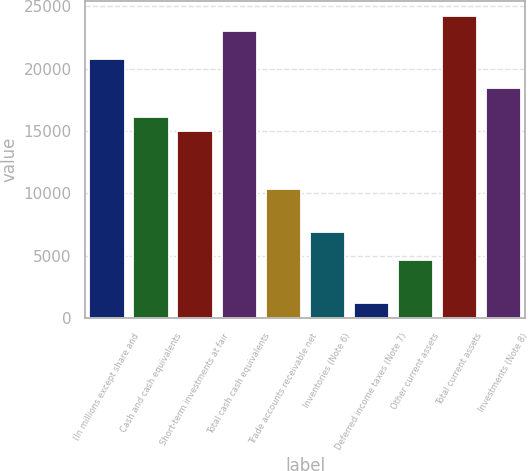Convert chart to OTSL. <chart><loc_0><loc_0><loc_500><loc_500><bar_chart><fcel>(In millions except share and<fcel>Cash and cash equivalents<fcel>Short-term investments at fair<fcel>Total cash cash equivalents<fcel>Trade accounts receivable net<fcel>Inventories (Note 6)<fcel>Deferred income taxes (Note 7)<fcel>Other current assets<fcel>Total current assets<fcel>Investments (Note 8)<nl><fcel>20752<fcel>16150<fcel>14999.5<fcel>23053<fcel>10397.5<fcel>6946<fcel>1193.5<fcel>4645<fcel>24203.5<fcel>18451<nl></chart> 